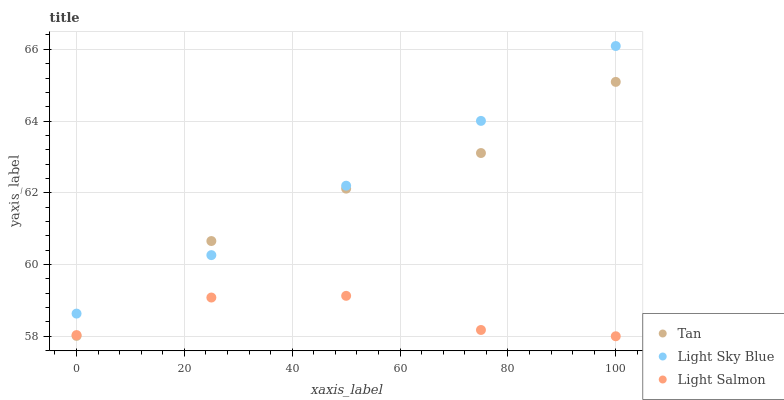Does Light Salmon have the minimum area under the curve?
Answer yes or no. Yes. Does Light Sky Blue have the maximum area under the curve?
Answer yes or no. Yes. Does Light Sky Blue have the minimum area under the curve?
Answer yes or no. No. Does Light Salmon have the maximum area under the curve?
Answer yes or no. No. Is Light Sky Blue the smoothest?
Answer yes or no. Yes. Is Light Salmon the roughest?
Answer yes or no. Yes. Is Light Salmon the smoothest?
Answer yes or no. No. Is Light Sky Blue the roughest?
Answer yes or no. No. Does Light Salmon have the lowest value?
Answer yes or no. Yes. Does Light Sky Blue have the lowest value?
Answer yes or no. No. Does Light Sky Blue have the highest value?
Answer yes or no. Yes. Does Light Salmon have the highest value?
Answer yes or no. No. Is Light Salmon less than Light Sky Blue?
Answer yes or no. Yes. Is Light Sky Blue greater than Light Salmon?
Answer yes or no. Yes. Does Light Sky Blue intersect Tan?
Answer yes or no. Yes. Is Light Sky Blue less than Tan?
Answer yes or no. No. Is Light Sky Blue greater than Tan?
Answer yes or no. No. Does Light Salmon intersect Light Sky Blue?
Answer yes or no. No. 